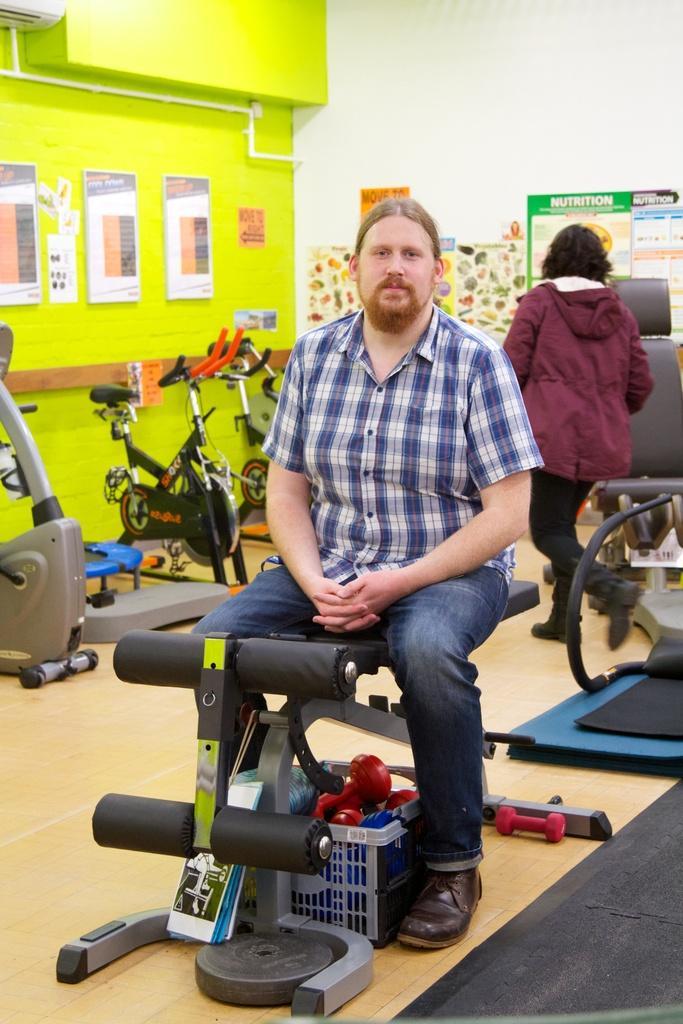How would you summarize this image in a sentence or two? There is a man sitting on an equipment in the foreground area of the image, there are exercise bikes, a person, posters and a pipe in the background. 